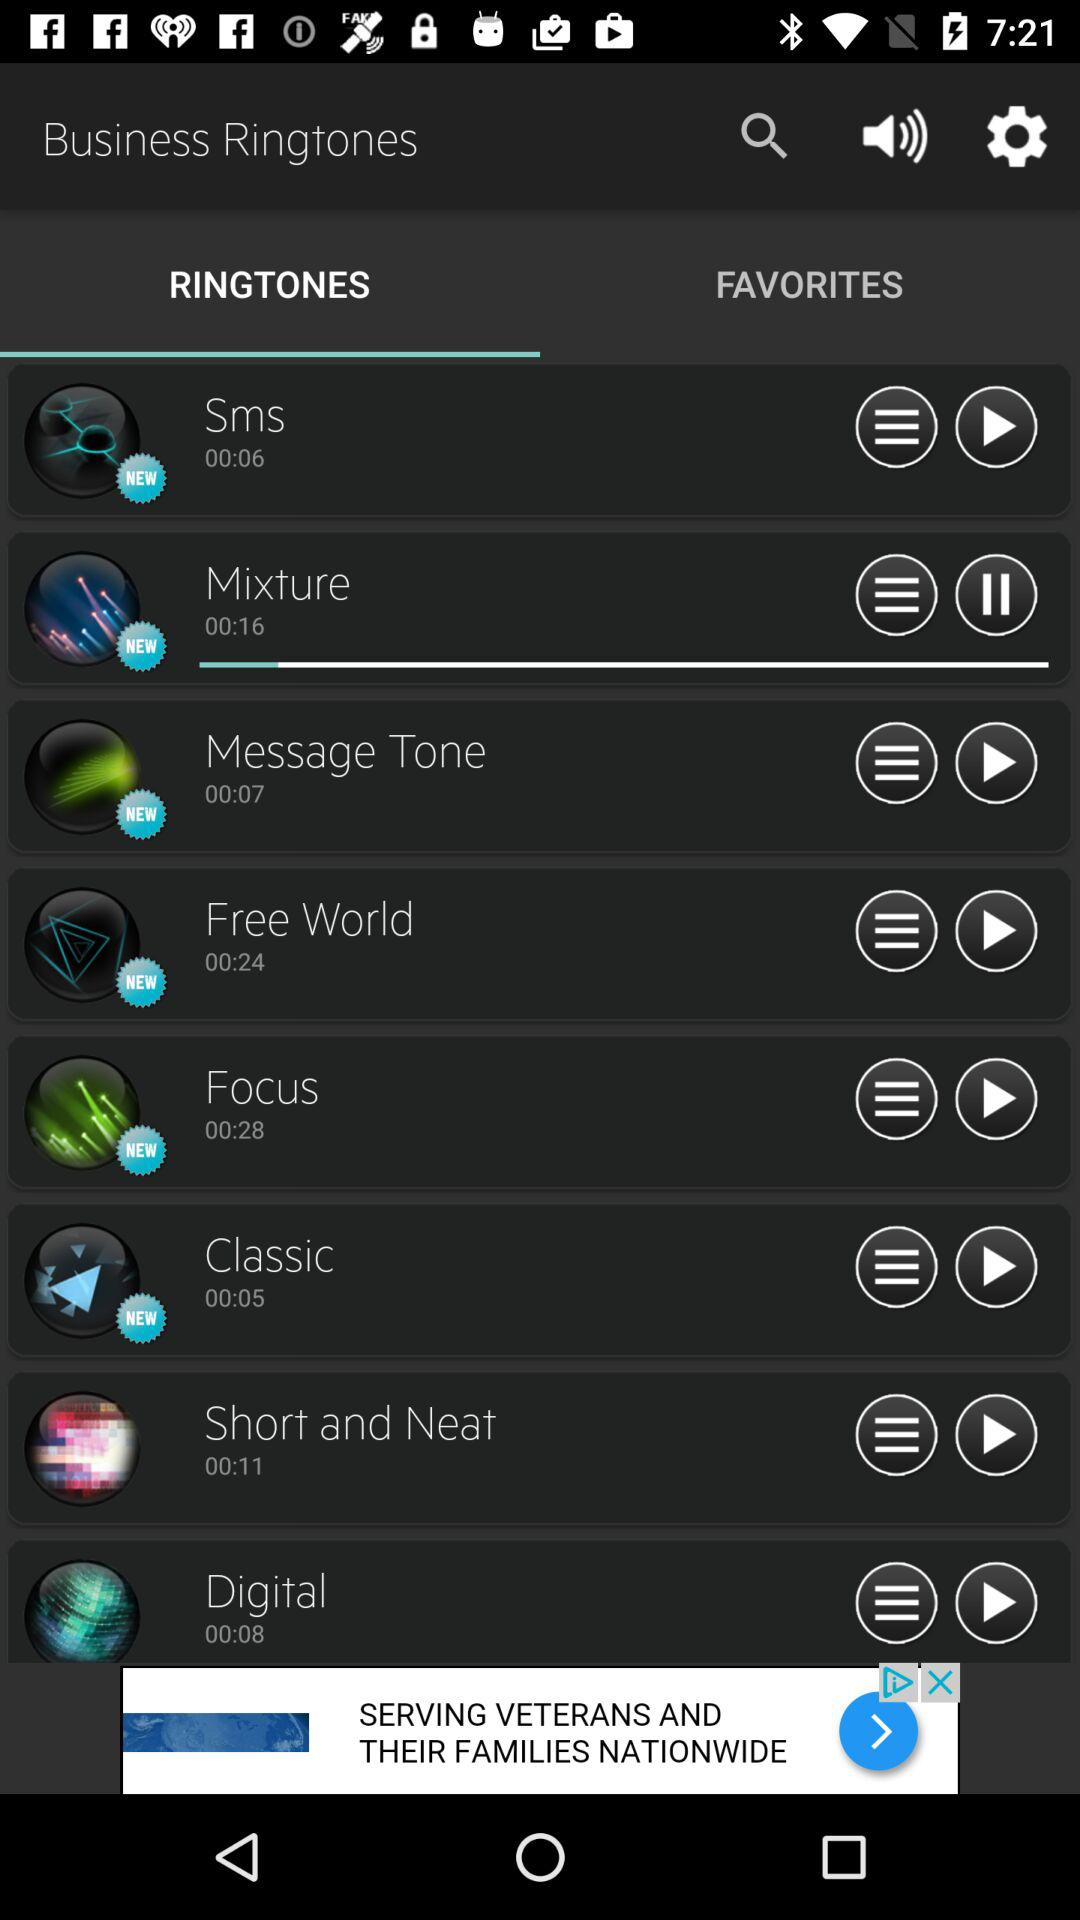How long is the message tone? The message tone is 7 seconds long. 